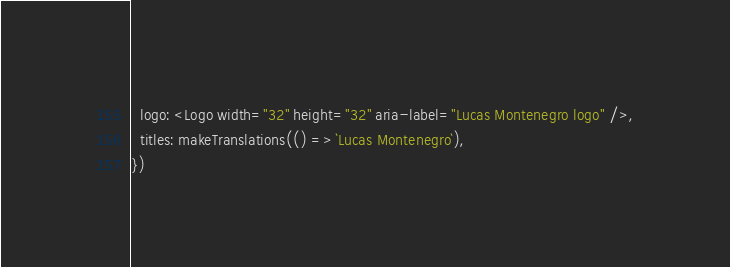Convert code to text. <code><loc_0><loc_0><loc_500><loc_500><_JavaScript_>  logo: <Logo width="32" height="32" aria-label="Lucas Montenegro logo" />,
  titles: makeTranslations(() => `Lucas Montenegro`),
})</code> 